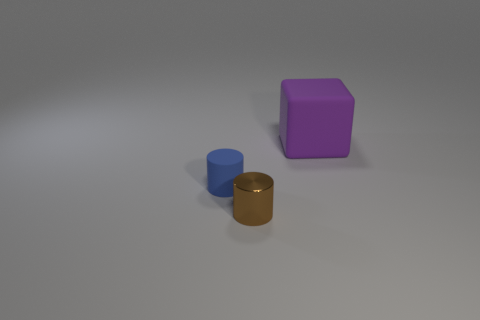Add 1 brown metal objects. How many objects exist? 4 Subtract all cylinders. How many objects are left? 1 Add 2 purple matte things. How many purple matte things are left? 3 Add 2 tiny blue objects. How many tiny blue objects exist? 3 Subtract 1 blue cylinders. How many objects are left? 2 Subtract 1 blocks. How many blocks are left? 0 Subtract all cyan cubes. Subtract all gray cylinders. How many cubes are left? 1 Subtract all purple balls. How many blue cylinders are left? 1 Subtract all large red shiny objects. Subtract all brown metal things. How many objects are left? 2 